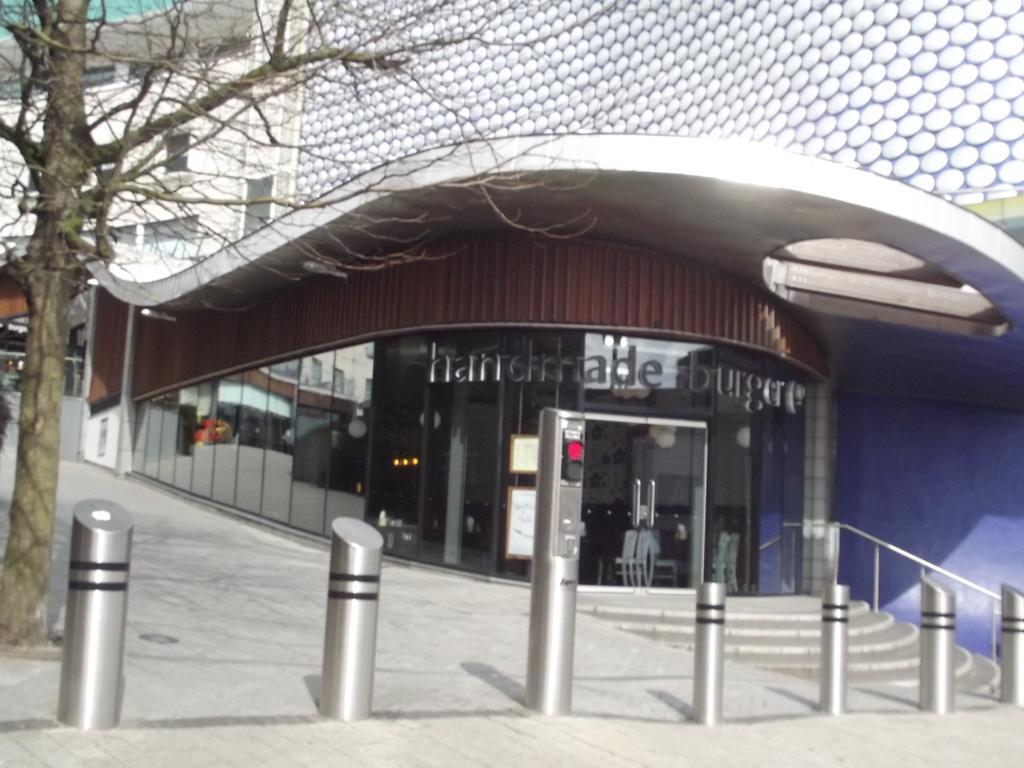How would you summarize this image in a sentence or two? In this image we can see a building with glass windows. This is tree. 